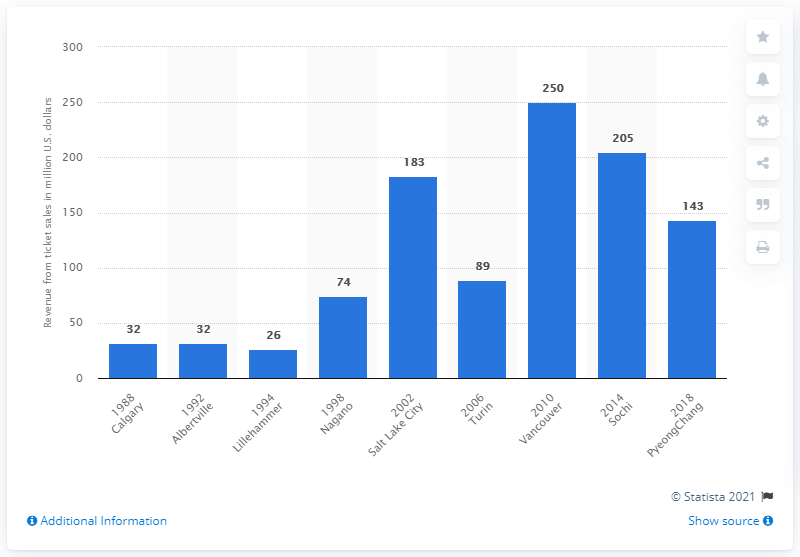Specify some key components in this picture. In 2006, the revenue of the Olympic Winter Games in Turin was 89 million dollars. The revenue from ticket sales for the Olympic Games in 1988 was allocated to the Organising Committee. The revenue generated from the Olympic Winter Games held in Albertville in 1992 and Nagano in 1998 differs by approximately 42 million dollars. 